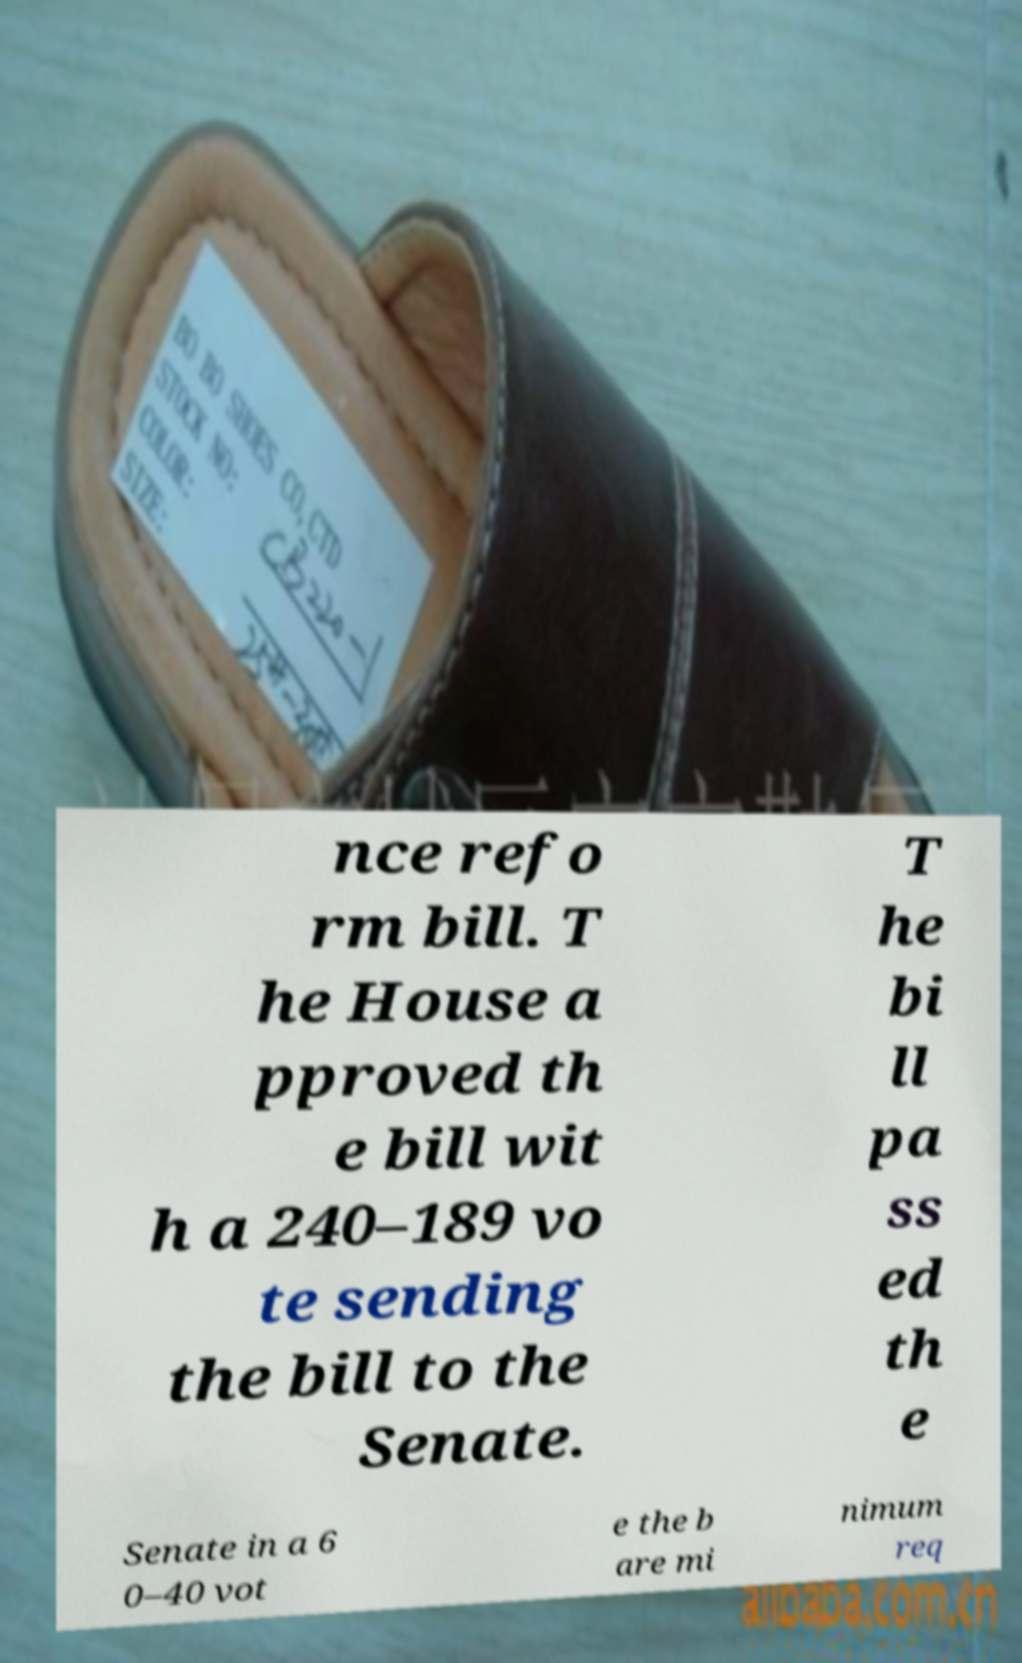Please read and relay the text visible in this image. What does it say? nce refo rm bill. T he House a pproved th e bill wit h a 240–189 vo te sending the bill to the Senate. T he bi ll pa ss ed th e Senate in a 6 0–40 vot e the b are mi nimum req 